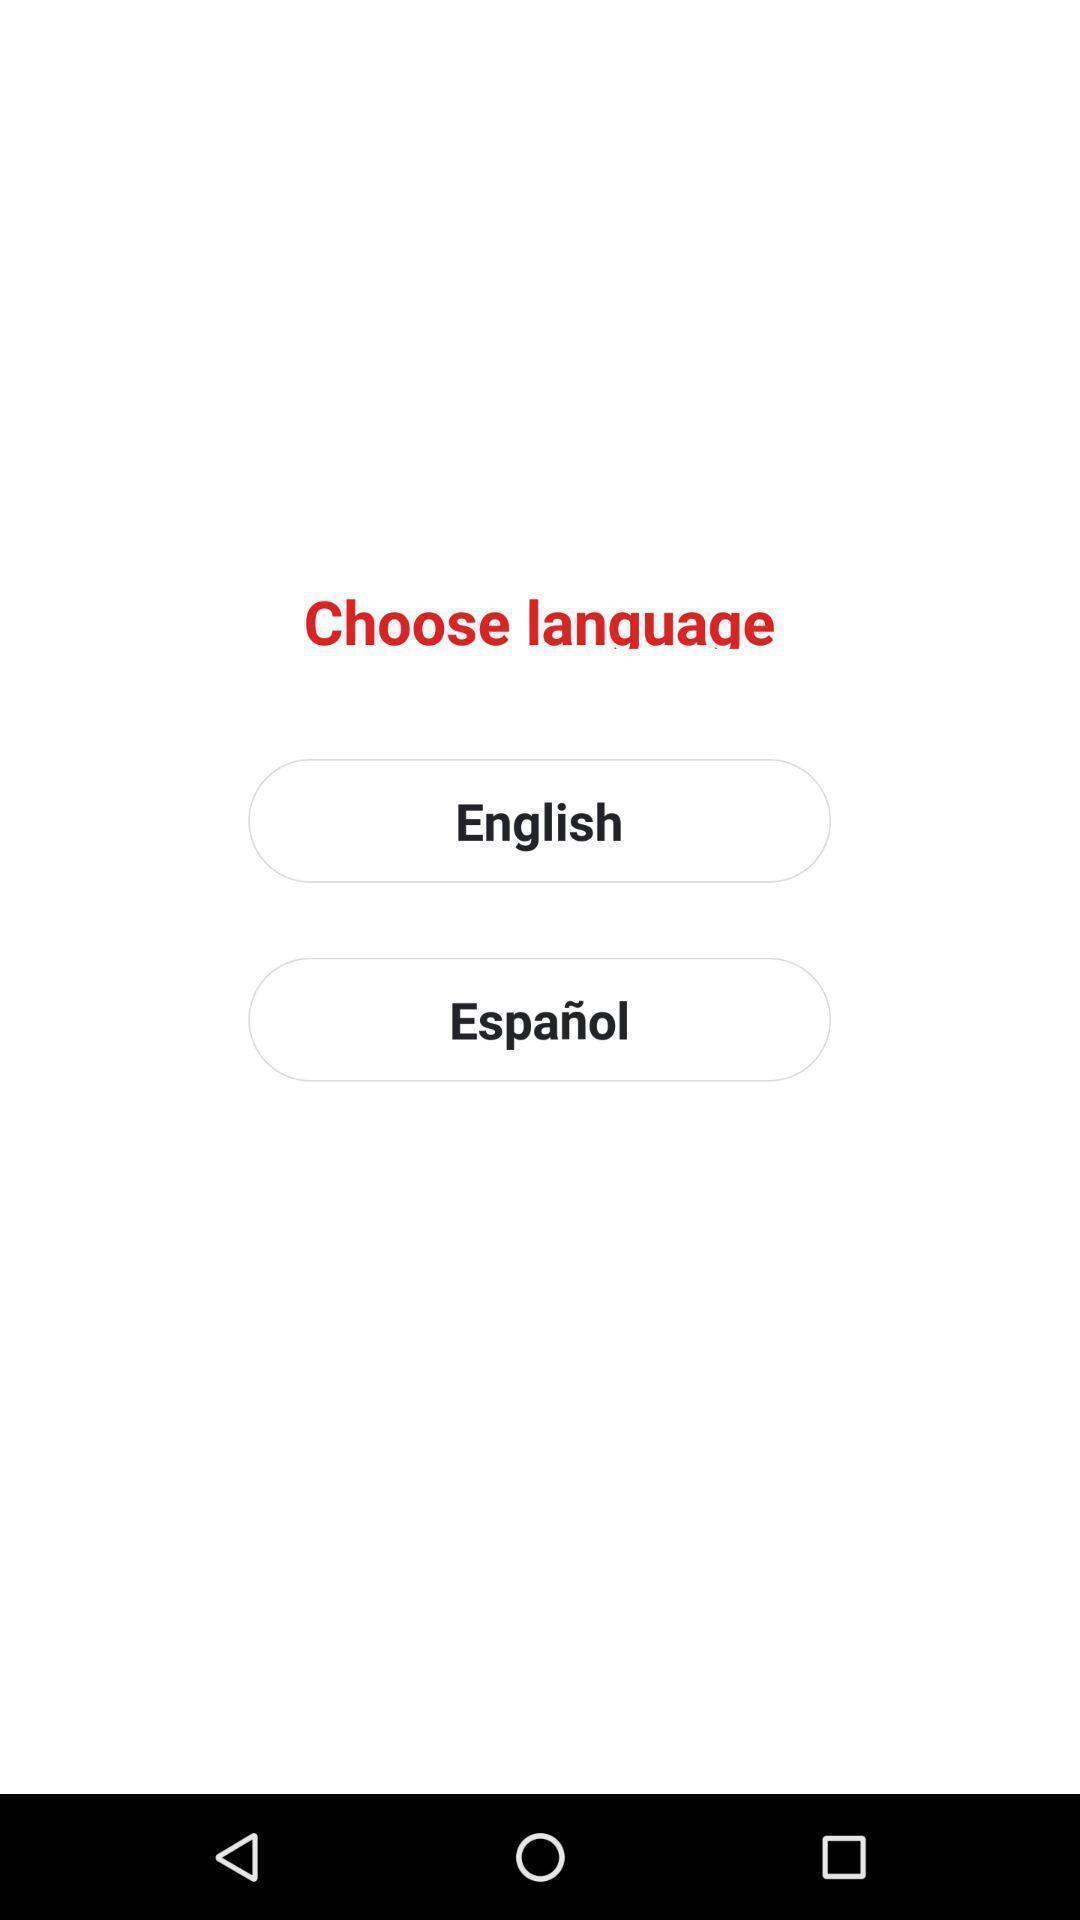Explain what's happening in this screen capture. Window displaying options to choose. 